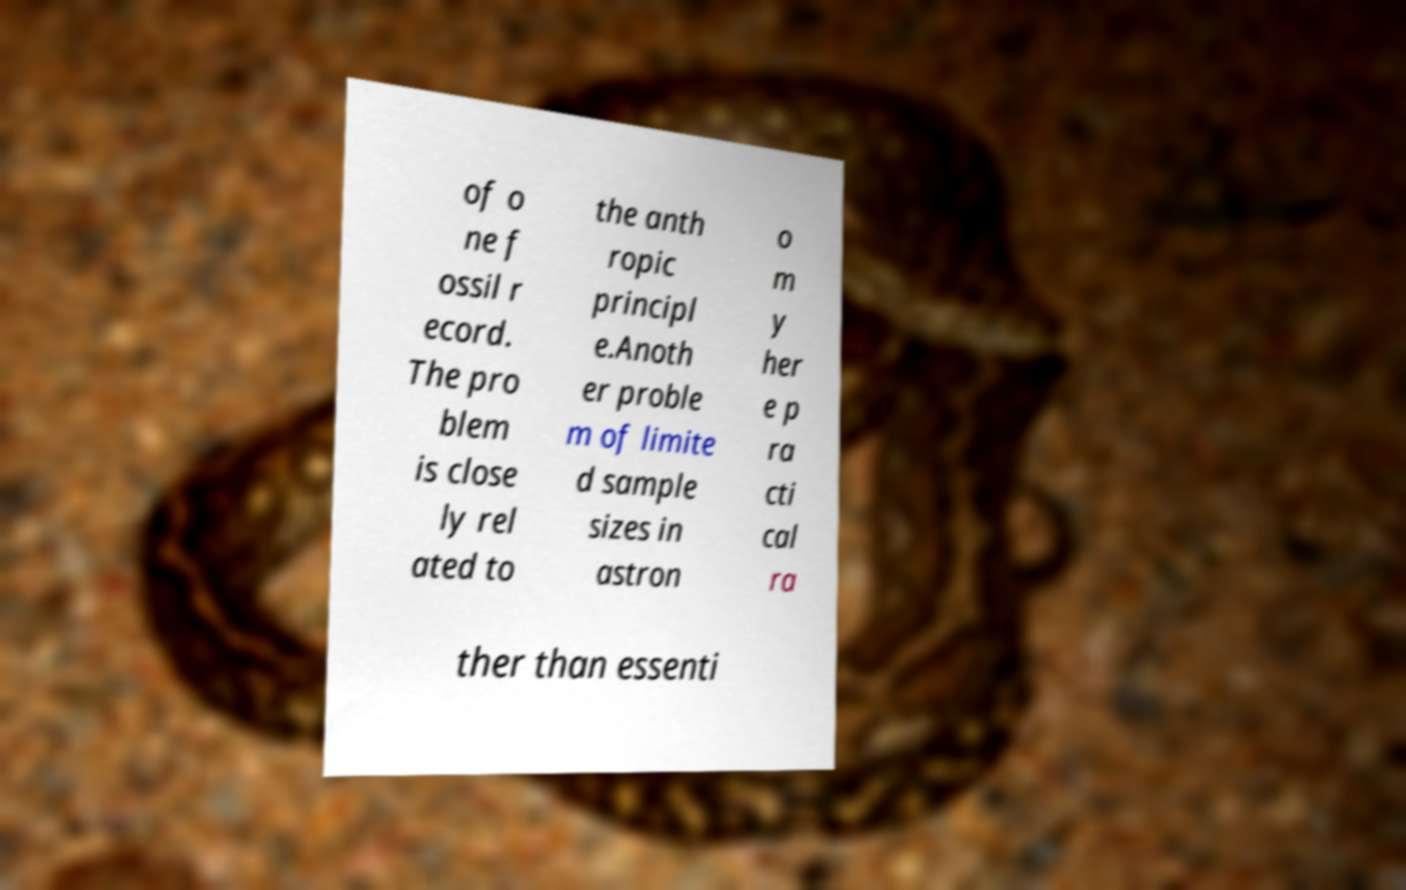Could you assist in decoding the text presented in this image and type it out clearly? of o ne f ossil r ecord. The pro blem is close ly rel ated to the anth ropic principl e.Anoth er proble m of limite d sample sizes in astron o m y her e p ra cti cal ra ther than essenti 